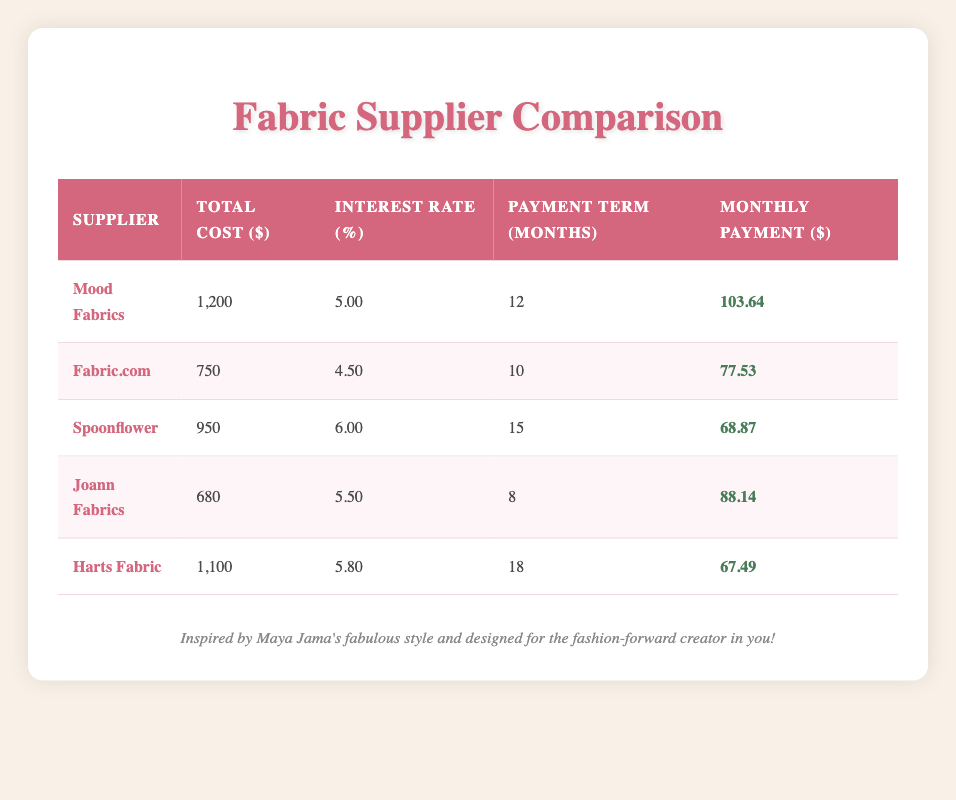What is the monthly payment for Mood Fabrics? The table specifies that the monthly payment for Mood Fabrics is listed in the corresponding row under the "Monthly Payment" column, which shows 103.64.
Answer: 103.64 Which supplier has the highest total cost? The total costs for each supplier are compared in the table, and Mood Fabrics has the highest total cost at 1200.
Answer: Mood Fabrics Is Fabric.com’s interest rate lower than Joann Fabrics’? Fabric.com has an interest rate of 4.5, while Joann Fabrics’ rate is 5.5. Since 4.5 is less than 5.5, the statement is true.
Answer: Yes What is the average monthly payment for all suppliers? To find the average, sum the monthly payments: (103.64 + 77.53 + 68.87 + 88.14 + 67.49) = 405.67. Then, divide by the number of suppliers (5), yielding an average of 81.13.
Answer: 81.13 Is the payment term for Spoonflower longer than that of Harts Fabric? Spooflower's payment term is 15 months, while Harts Fabric is 18 months. Since 15 is less than 18, the statement is false.
Answer: No What is the difference in monthly payment between the lowest and highest? The lowest monthly payment is for Harts Fabric at 67.49, and the highest is for Mood Fabrics at 103.64. To find the difference: 103.64 - 67.49 = 36.15.
Answer: 36.15 Which fabric supplier has the lowest total cost, and what is the monthly payment? The table shows that Joann Fabrics has the lowest total cost at 680, and the corresponding monthly payment is 88.14.
Answer: Joann Fabrics, 88.14 If I combine the total costs of Fabric.com and Spoonflower, what will that be? The total cost for Fabric.com is 750 and for Spoonflower is 950. Adding these together gives 750 + 950 = 1700.
Answer: 1700 Which supplier has both a higher total cost and interest rate than Joann Fabrics? Joann Fabrics has a total cost of 680 and an interest rate of 5.5. Comparing with the other suppliers, Harts Fabric has a total cost of 1100 and an interest rate of 5.8. Therefore, Harts Fabric meets both criteria.
Answer: Harts Fabric 